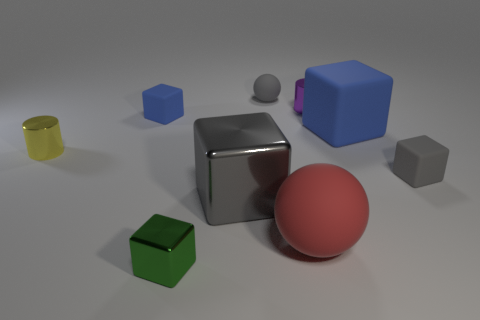What number of big brown cylinders are there?
Ensure brevity in your answer.  0. The tiny matte cube to the right of the blue block that is to the left of the tiny gray rubber thing that is on the left side of the big red rubber ball is what color?
Ensure brevity in your answer.  Gray. Is the number of large purple balls less than the number of big blue cubes?
Give a very brief answer. Yes. There is another big thing that is the same shape as the large gray metallic thing; what color is it?
Your response must be concise. Blue. There is another big object that is the same material as the red object; what color is it?
Offer a terse response. Blue. How many matte blocks are the same size as the gray sphere?
Offer a very short reply. 2. What material is the tiny purple cylinder?
Offer a very short reply. Metal. Is the number of big shiny blocks greater than the number of large brown blocks?
Offer a terse response. Yes. Is the shape of the large blue thing the same as the small yellow thing?
Make the answer very short. No. There is a big object that is behind the yellow cylinder; is it the same color as the small matte object that is on the left side of the green cube?
Your answer should be very brief. Yes. 